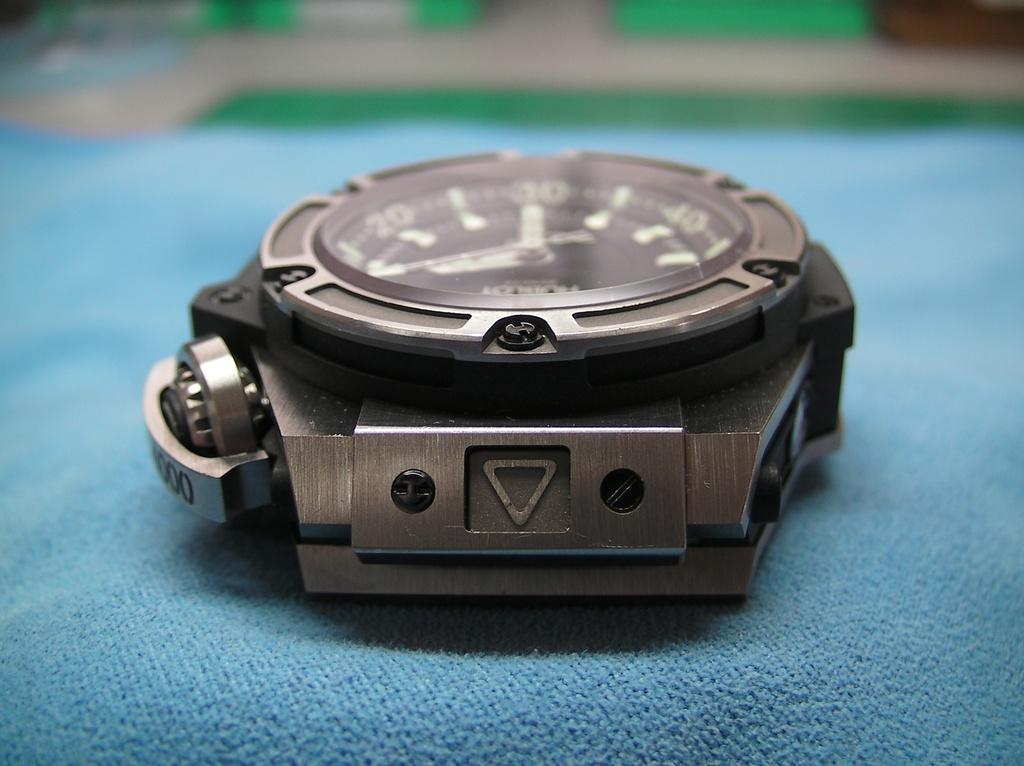Provide a one-sentence caption for the provided image. A strapless watch face with three zeros on the edge of it. 